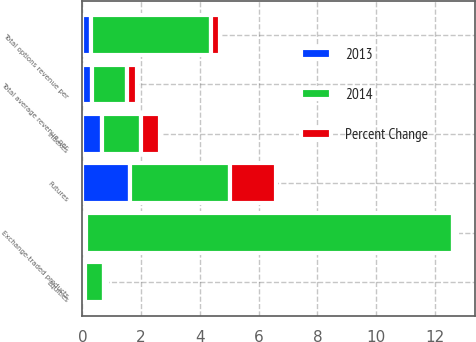Convert chart to OTSL. <chart><loc_0><loc_0><loc_500><loc_500><stacked_bar_chart><ecel><fcel>Equities<fcel>Indexes<fcel>Exchange-traded products<fcel>Total options revenue per<fcel>Futures<fcel>Total average revenue per<nl><fcel>2013<fcel>0.08<fcel>0.68<fcel>0.11<fcel>0.28<fcel>1.62<fcel>0.33<nl><fcel>Percent Change<fcel>0.09<fcel>0.67<fcel>0.13<fcel>0.29<fcel>1.57<fcel>0.33<nl><fcel>2014<fcel>0.67<fcel>1.3<fcel>12.5<fcel>4.1<fcel>3.4<fcel>1.2<nl></chart> 